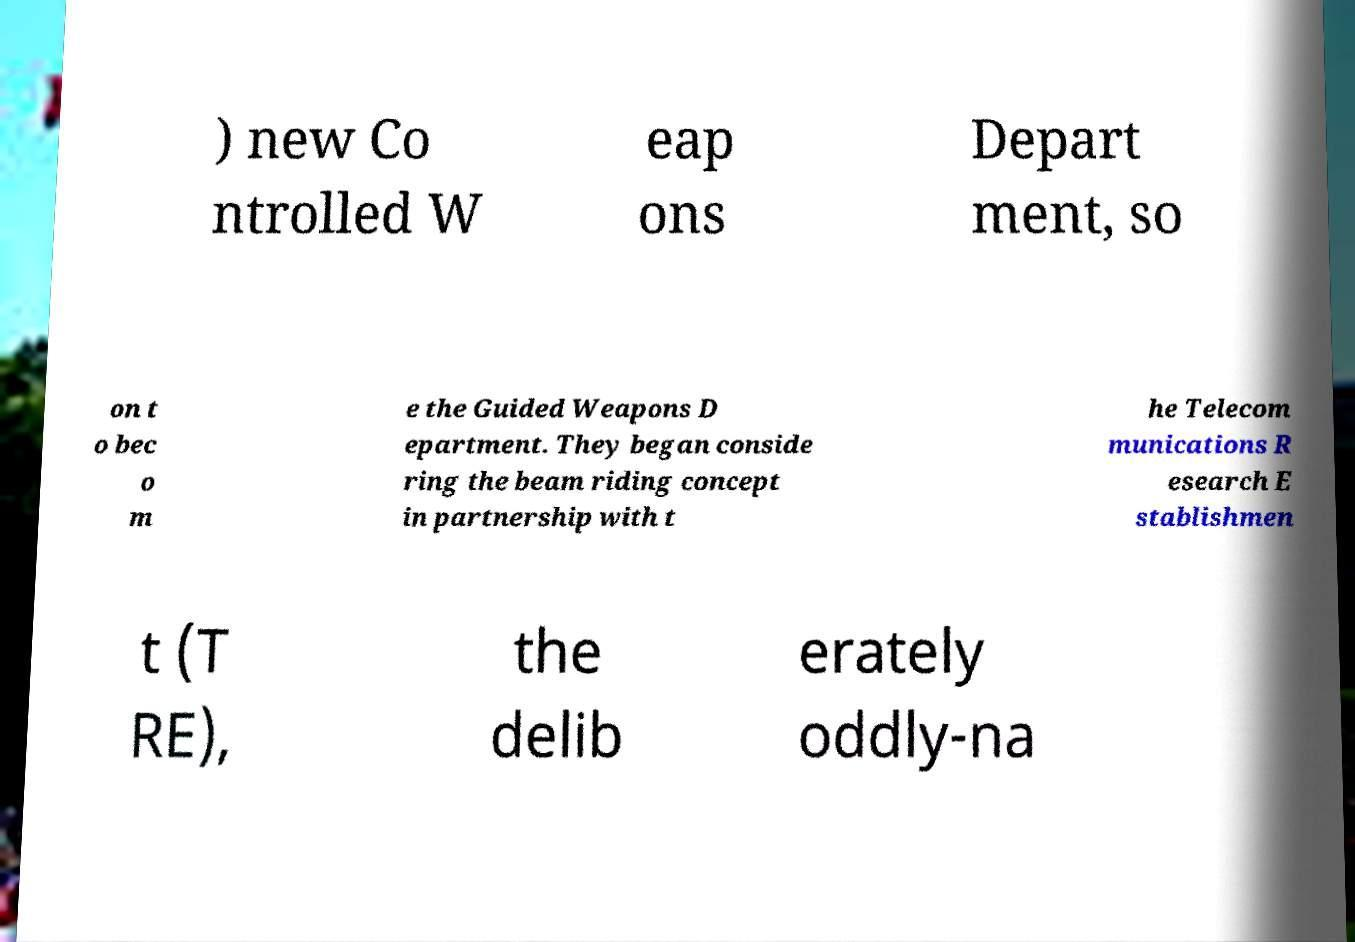Can you accurately transcribe the text from the provided image for me? ) new Co ntrolled W eap ons Depart ment, so on t o bec o m e the Guided Weapons D epartment. They began conside ring the beam riding concept in partnership with t he Telecom munications R esearch E stablishmen t (T RE), the delib erately oddly-na 